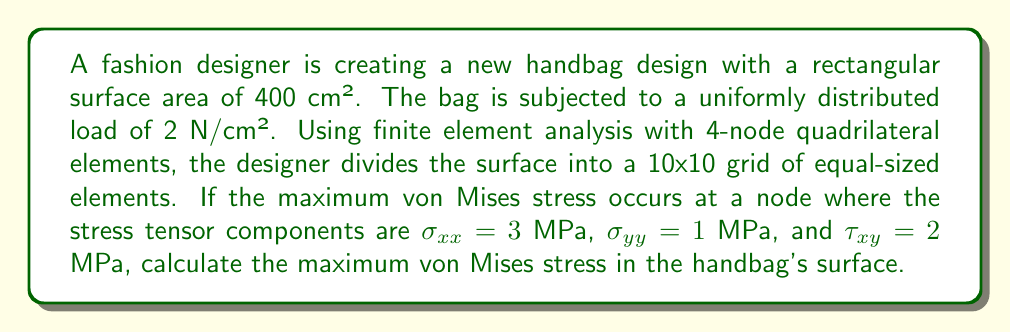Show me your answer to this math problem. To solve this problem, we'll follow these steps:

1. Understand the given information:
   - Surface area: 400 cm²
   - Uniformly distributed load: 2 N/cm²
   - FEA mesh: 10x10 grid of 4-node quadrilateral elements
   - Stress tensor components at max stress node: $\sigma_{xx} = 3$ MPa, $\sigma_{yy} = 1$ MPa, $\tau_{xy} = 2$ MPa

2. Recall the von Mises stress formula for 2D plane stress:
   $$\sigma_{vm} = \sqrt{\sigma_{xx}^2 + \sigma_{yy}^2 - \sigma_{xx}\sigma_{yy} + 3\tau_{xy}^2}$$

3. Substitute the given stress components into the formula:
   $$\sigma_{vm} = \sqrt{(3\text{ MPa})^2 + (1\text{ MPa})^2 - (3\text{ MPa})(1\text{ MPa}) + 3(2\text{ MPa})^2}$$

4. Simplify and calculate:
   $$\sigma_{vm} = \sqrt{9 + 1 - 3 + 3(4)} = \sqrt{7 + 12} = \sqrt{19} \text{ MPa}$$

5. The result is an irrational number, so we'll leave it in square root form.
Answer: $\sqrt{19}$ MPa 